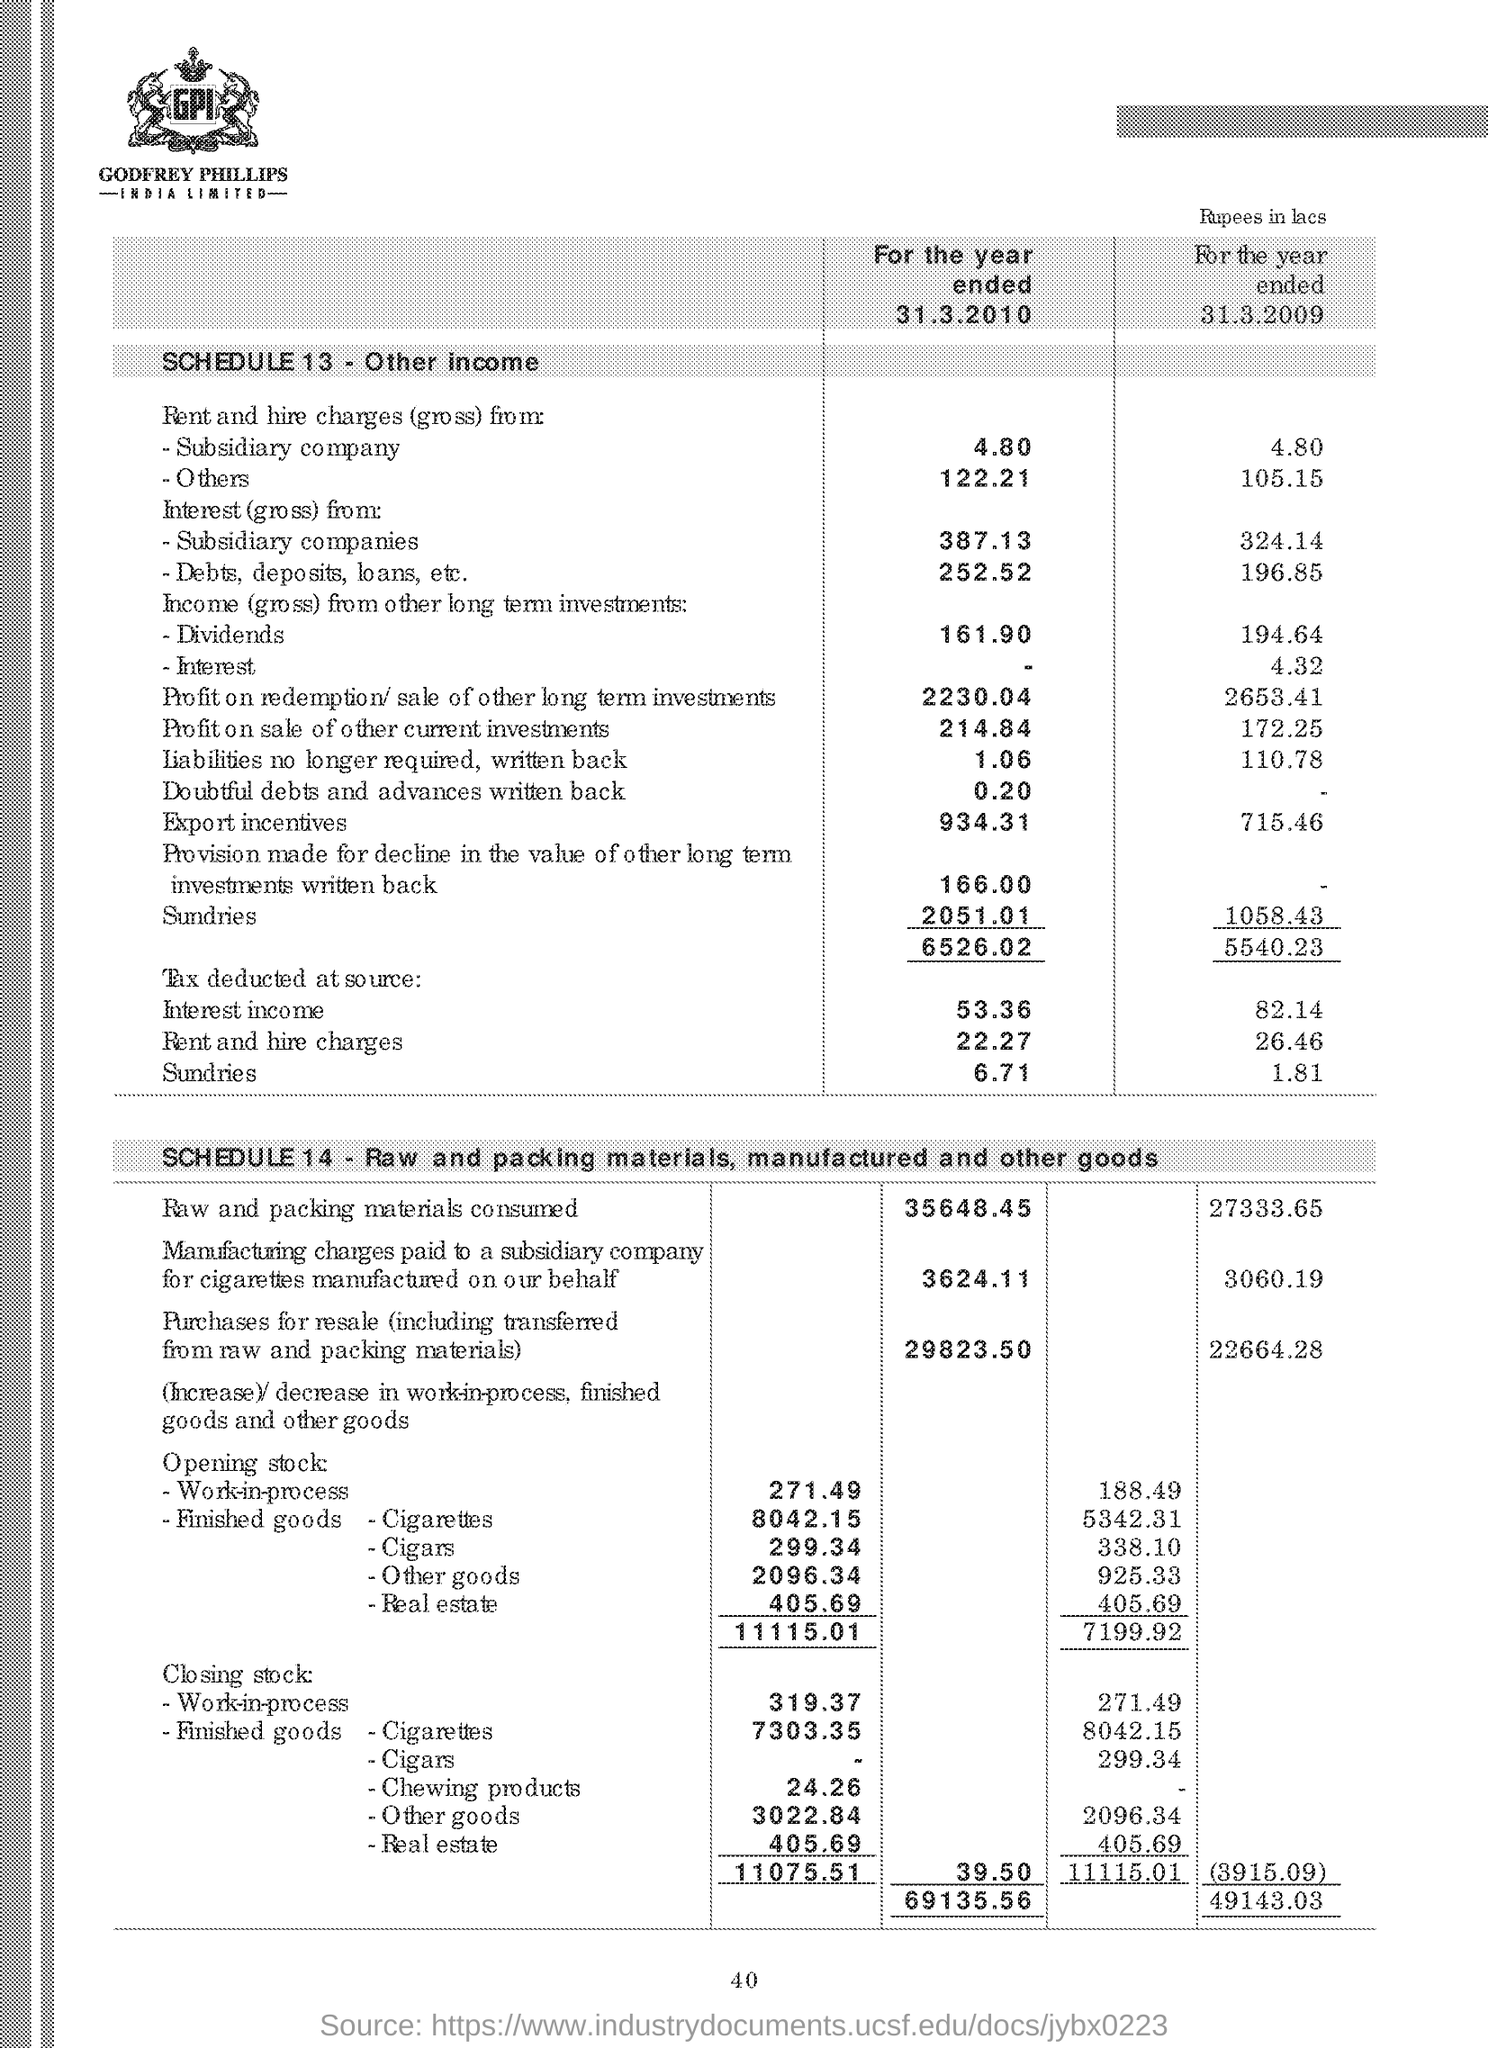What is schedule 13?
Ensure brevity in your answer.  Other income. How much is the raw and packing materials consumed for the year 2010?
Your answer should be compact. 35648.45. 